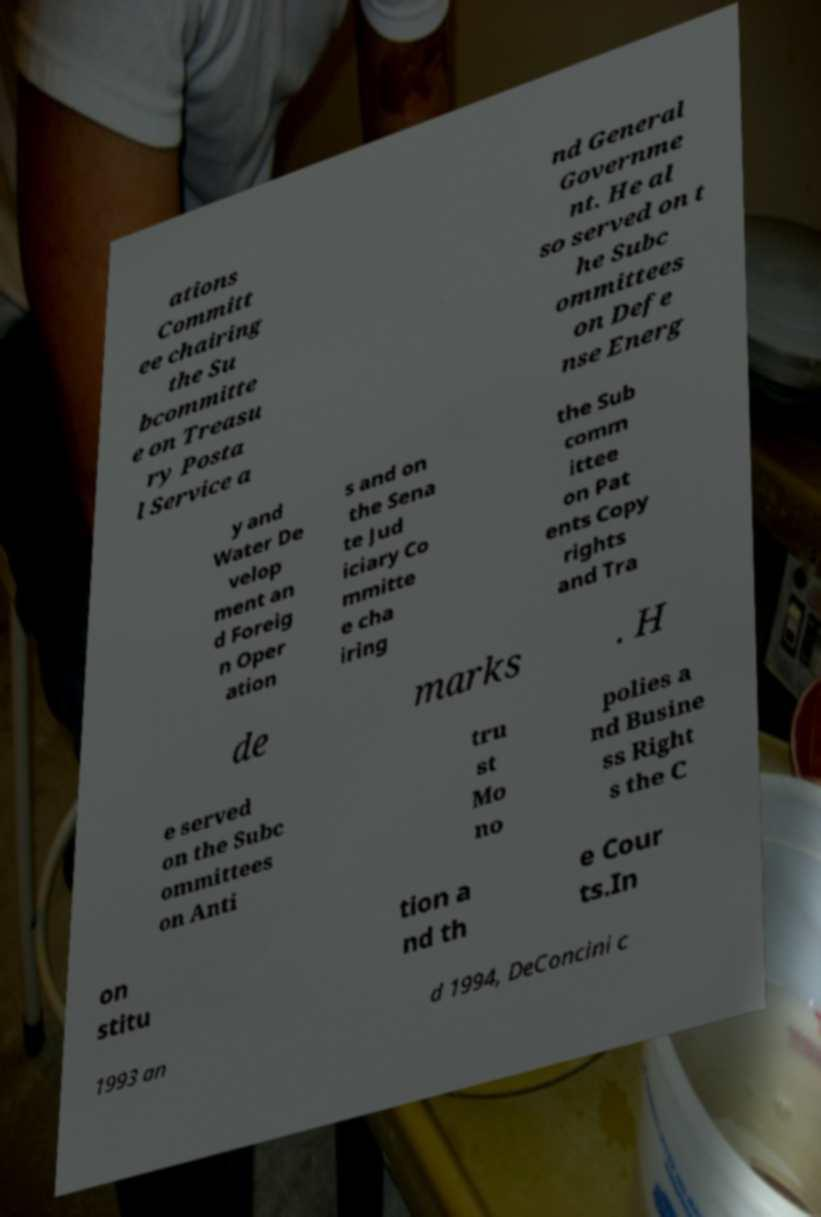Please identify and transcribe the text found in this image. ations Committ ee chairing the Su bcommitte e on Treasu ry Posta l Service a nd General Governme nt. He al so served on t he Subc ommittees on Defe nse Energ y and Water De velop ment an d Foreig n Oper ation s and on the Sena te Jud iciary Co mmitte e cha iring the Sub comm ittee on Pat ents Copy rights and Tra de marks . H e served on the Subc ommittees on Anti tru st Mo no polies a nd Busine ss Right s the C on stitu tion a nd th e Cour ts.In 1993 an d 1994, DeConcini c 